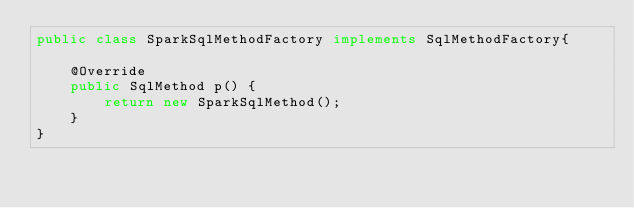Convert code to text. <code><loc_0><loc_0><loc_500><loc_500><_Java_>public class SparkSqlMethodFactory implements SqlMethodFactory{

    @Override
    public SqlMethod p() {
        return new SparkSqlMethod();
    }
}
</code> 